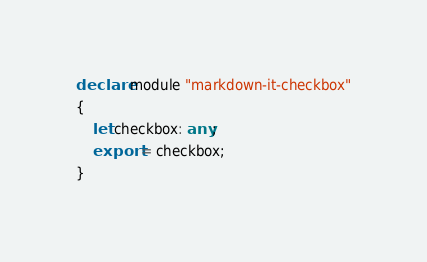<code> <loc_0><loc_0><loc_500><loc_500><_TypeScript_>declare module "markdown-it-checkbox"
{
    let checkbox: any;
    export = checkbox;
}
</code> 